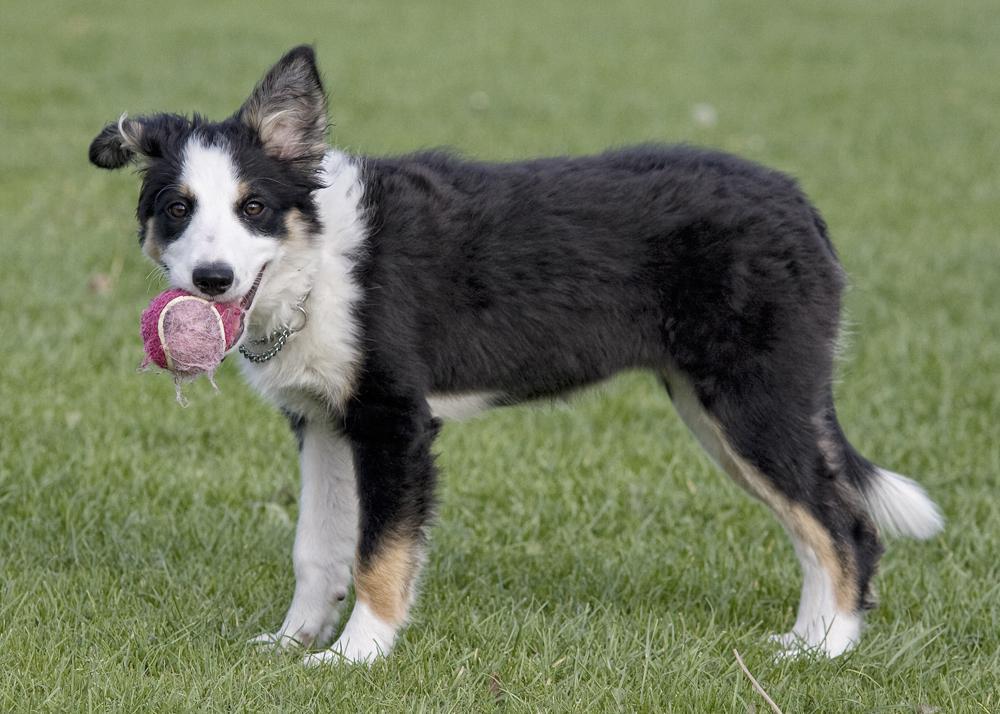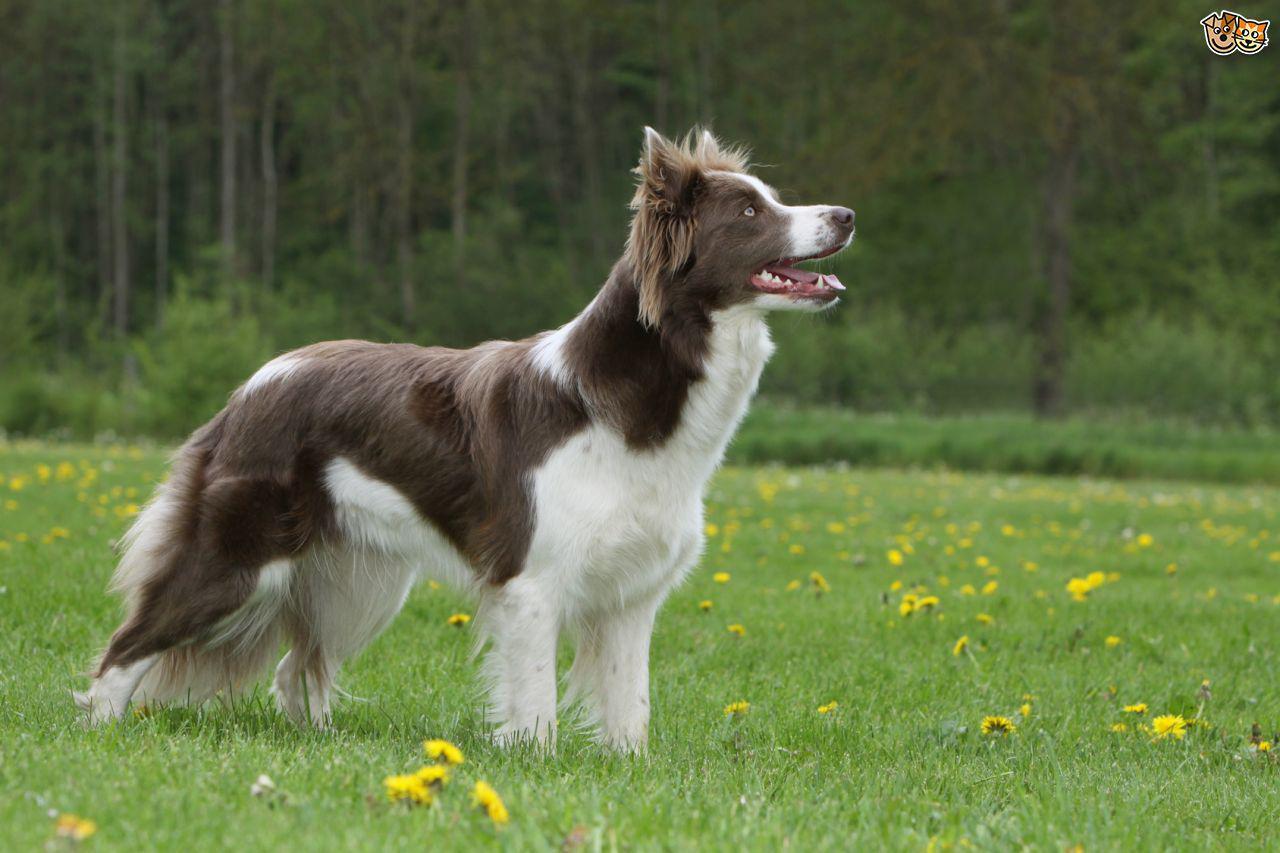The first image is the image on the left, the second image is the image on the right. Considering the images on both sides, is "An image shows a standing dog in profile facing right." valid? Answer yes or no. Yes. The first image is the image on the left, the second image is the image on the right. Analyze the images presented: Is the assertion "One of the images shows exactly two dogs." valid? Answer yes or no. No. 